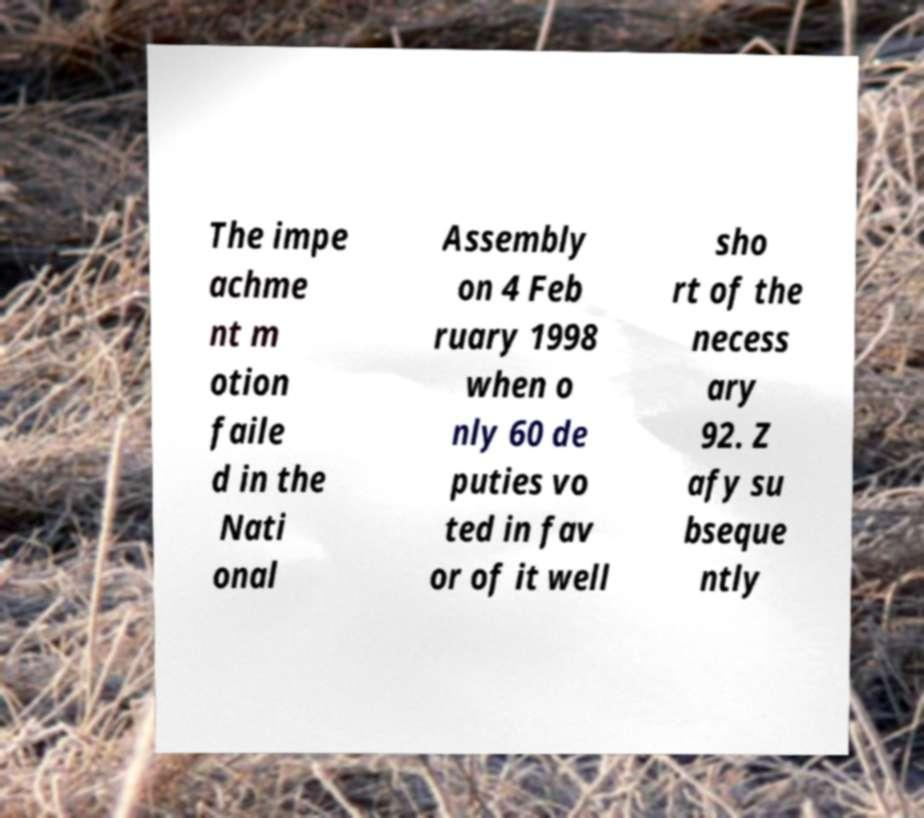I need the written content from this picture converted into text. Can you do that? The impe achme nt m otion faile d in the Nati onal Assembly on 4 Feb ruary 1998 when o nly 60 de puties vo ted in fav or of it well sho rt of the necess ary 92. Z afy su bseque ntly 